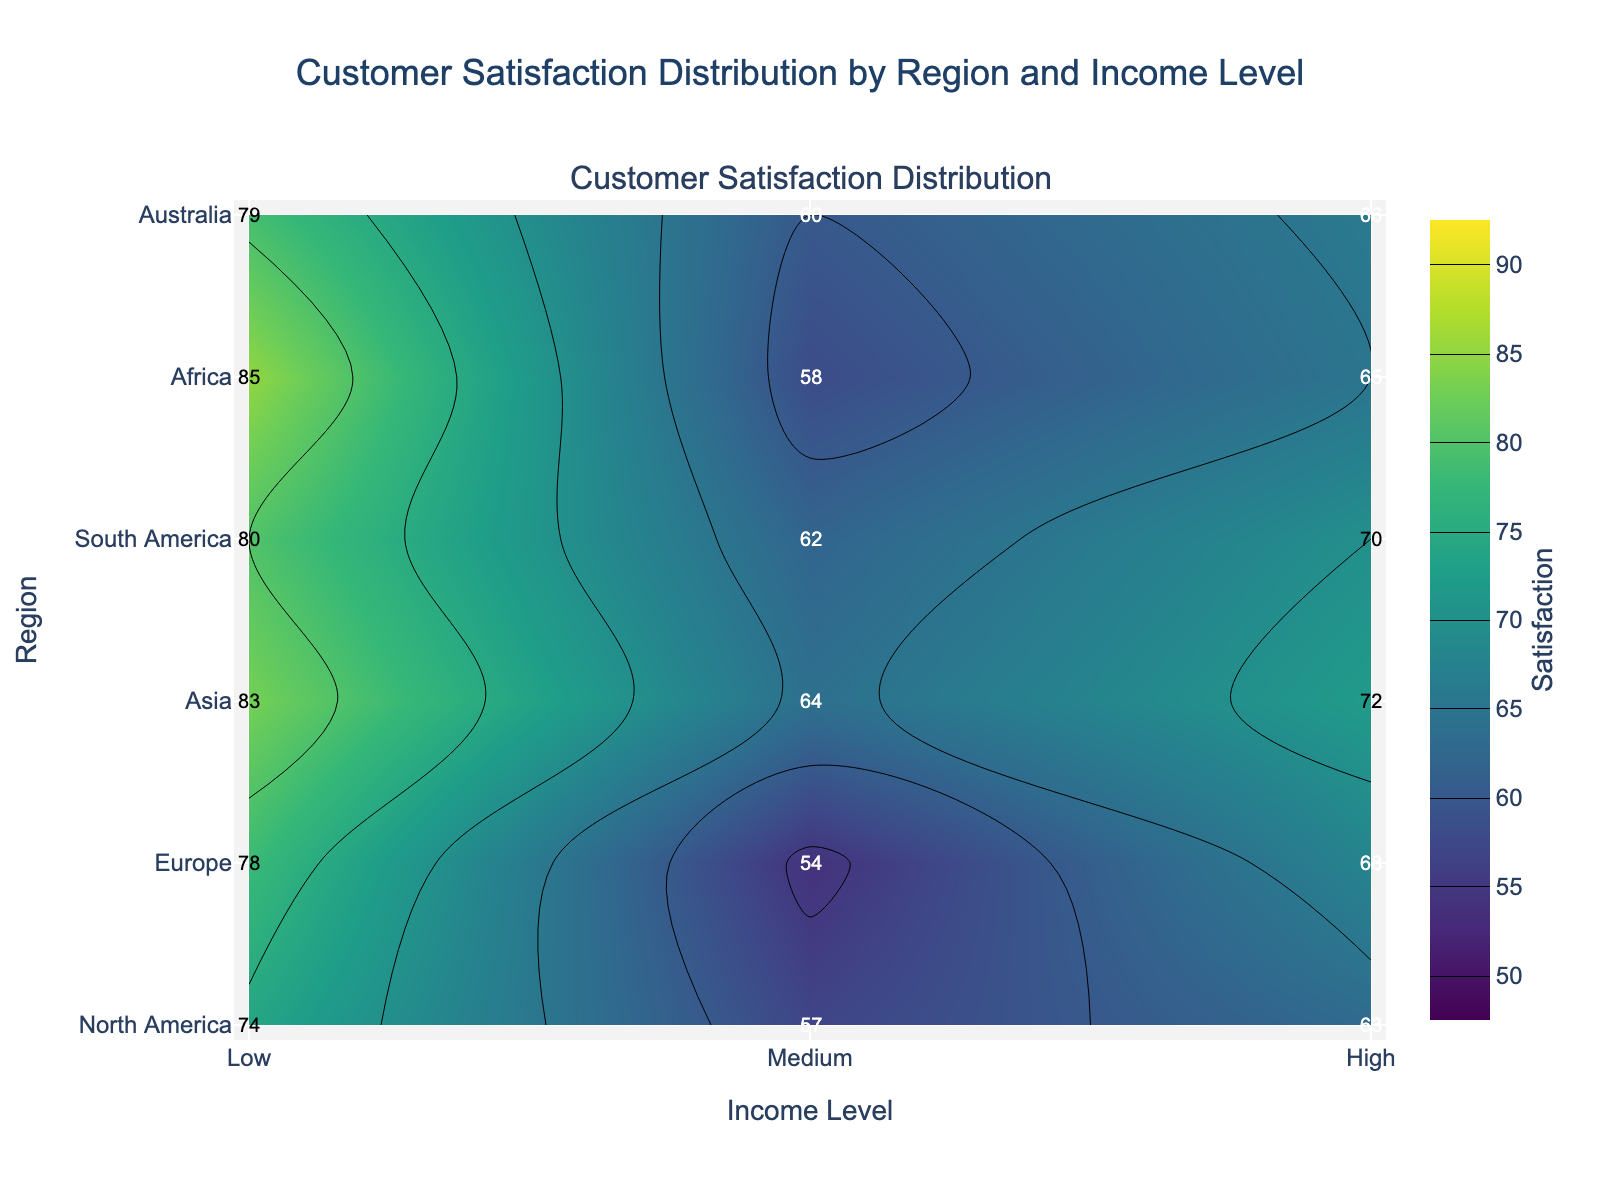What is the title of the plot? The title of the plot is prominently displayed at the top. It reads, "Customer Satisfaction Distribution by Region and Income Level."
Answer: Customer Satisfaction Distribution by Region and Income Level Which region shows the highest customer satisfaction in the low-income level? Looking at the low-income level across different regions on the y-axis and matching it with the z-values on the plot, Australia exhibits the highest satisfaction score in the low-income level which is 64.
Answer: Australia Is the customer satisfaction higher in Europe or Asia for the medium-income level? By comparing the satisfaction scores at the medium-income level for Europe and Asia, Europe has a score of 70 and Asia has a score of 68. Thus, Europe has a higher customer satisfaction.
Answer: Europe What is the difference in customer satisfaction between North America and Africa at the high-income level? Referring to the high-income level and looking at the satisfaction values for North America and Africa, these are 85 and 74, respectively. Therefore, the difference is 85 - 74 = 11.
Answer: 11 Which income level in South America shows the lowest customer satisfaction? The customer satisfaction values for South America are examined across low, medium, and high-income levels. The scores are 60, 66, and 79, respectively. Therefore, the lowest score is at the low-income level, i.e., 60.
Answer: Low What is the average customer satisfaction in Europe across all income levels? Identifying the satisfaction scores for Europe, which are 62 (low), 70 (medium), and 80 (high). Calculating the average: (62 + 70 + 80) / 3 = 70.67.
Answer: 70.67 Which region has the smallest range of customer satisfaction scores across different income levels? Calculate the range for each region by subtracting the lowest score from the highest score. The ranges are: North America: 85-58=27, Europe: 80-62=18, Asia: 78-54=24, South America: 79-60=19, Africa: 74-57=17, Australia: 83-64=19. Hence, Africa has the smallest range with a difference of 17.
Answer: Africa How does customer satisfaction in the medium-income level compare across all regions? Assessing the plot at the medium-income level shows satisfaction scores: North America (65), Europe (70), Asia (68), South America (66), Africa (63), and Australia (72). Australia scores the highest and Africa scores the lowest in the medium-income level.
Answer: Australia has the highest, Africa has the lowest What is the trend of customer satisfaction from low to high-income levels within the Asia region? Observing the satisfaction scores in Asia for low (54), medium (68), and high (78) income levels, we see an upward trend in customer satisfaction as income level increases.
Answer: Increasing Between North America and Australia, which has a greater improvement in satisfaction from medium to high-income levels? The improvement in satisfaction is calculated by subtracting the medium score from the high score for each region: North America (85-65=20), Australia (83-72=11). North America shows a greater improvement.
Answer: North America 